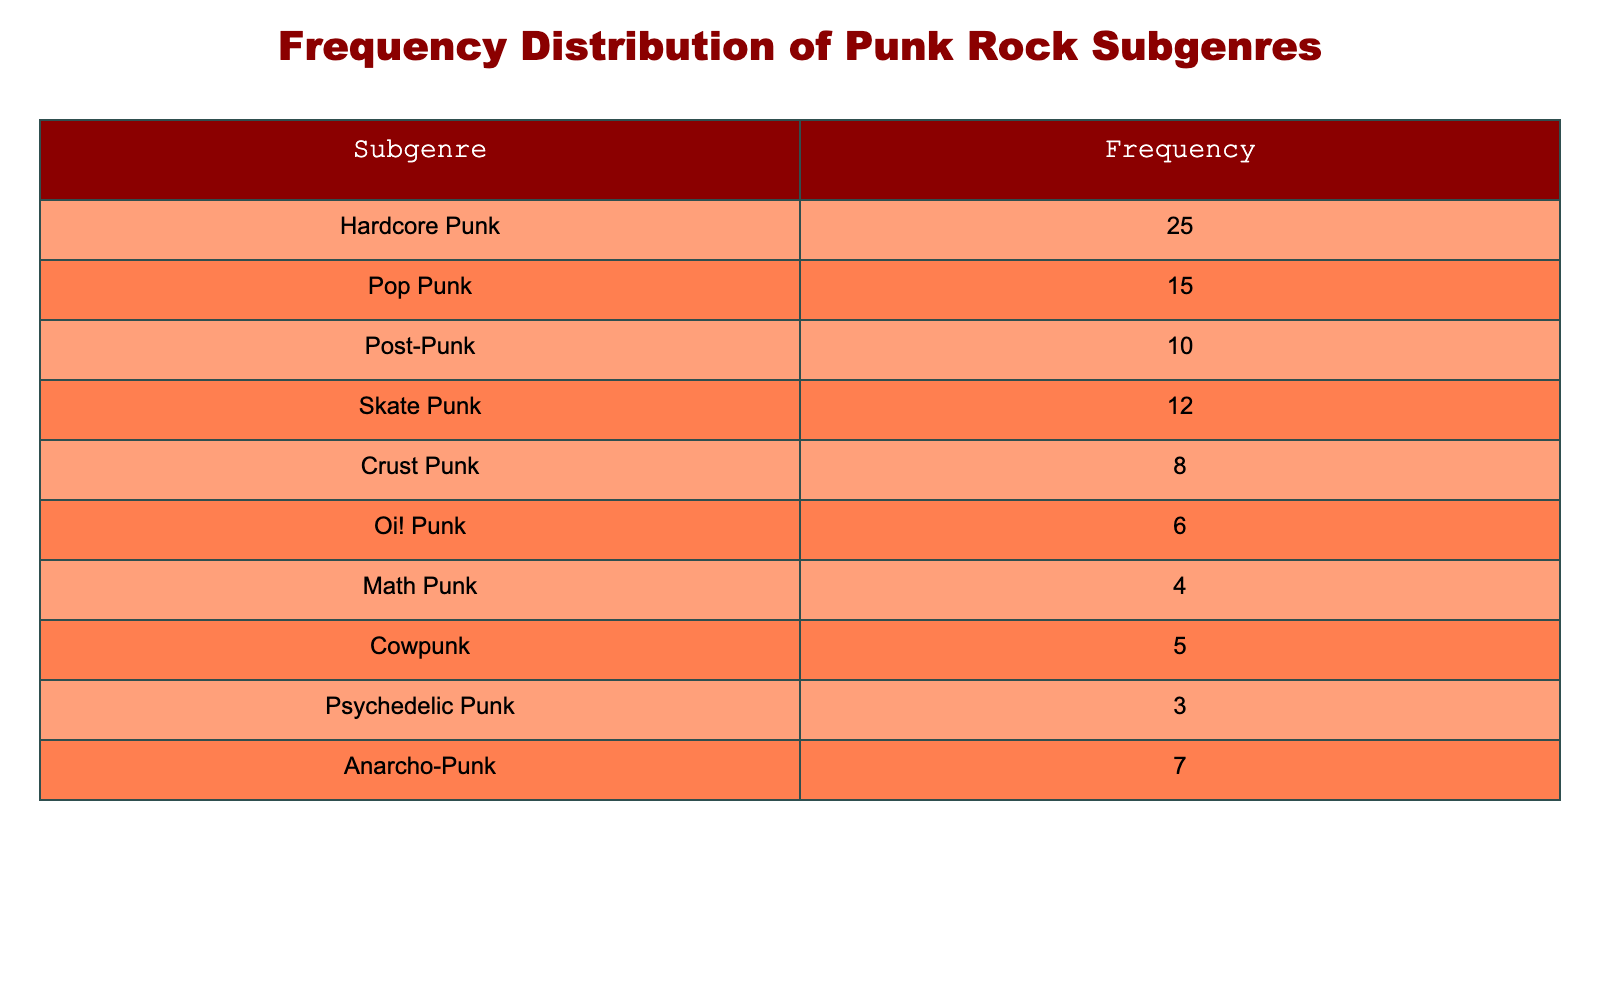What is the most performed punk rock subgenre at local shows? The table lists the subgenres and their corresponding frequencies. By comparing the numbers, Hardcore Punk has the highest frequency at 25 performances.
Answer: Hardcore Punk How many times was Crust Punk performed? The table directly shows that Crust Punk has a frequency of 8 performances.
Answer: 8 What is the combined frequency of Pop Punk and Skate Punk? We add the frequencies of Pop Punk (15) and Skate Punk (12). Therefore, the combined frequency is 15 + 12 = 27.
Answer: 27 Is the frequency of Oi! Punk greater than that of Math Punk? By looking at the table, Oi! Punk has a frequency of 6, while Math Punk has a frequency of 4. Since 6 is greater than 4, the statement is true.
Answer: Yes What is the average frequency of the subgenres listed in the table? To find the average, we sum all the frequencies: 25 (Hardcore Punk) + 15 (Pop Punk) + 10 (Post-Punk) + 12 (Skate Punk) + 8 (Crust Punk) + 6 (Oi! Punk) + 4 (Math Punk) + 5 (Cowpunk) + 3 (Psychedelic Punk) + 7 (Anarcho-Punk) = 95. There are 10 subgenres, so the average is 95 / 10 = 9.5.
Answer: 9.5 Which punk rock subgenre has the least performance frequency and how many times was it performed? The table shows that Psychedelic Punk has the lowest frequency of 3 performances.
Answer: Psychedelic Punk, 3 What is the difference in frequency between Hardcore Punk and Oi! Punk? The frequency for Hardcore Punk is 25 and for Oi! Punk is 6. To find the difference, we subtract: 25 - 6 = 19.
Answer: 19 Is the total frequency of all the subgenres less than 100? The total frequency of all the subgenres is 95, which is indeed less than 100. Therefore, the answer is yes.
Answer: Yes Which subgenre has a frequency closest to the median of all the frequencies? The median frequency can be found by sorting the frequencies: 3, 4, 5, 6, 7, 8, 10, 12, 15, 25 — with a total of 10 values, the median is the average of the 5th and 6th values: (7 + 8) / 2 = 7.5. The subgenre closest to this is Anarcho-Punk with 7.
Answer: Anarcho-Punk, 7 